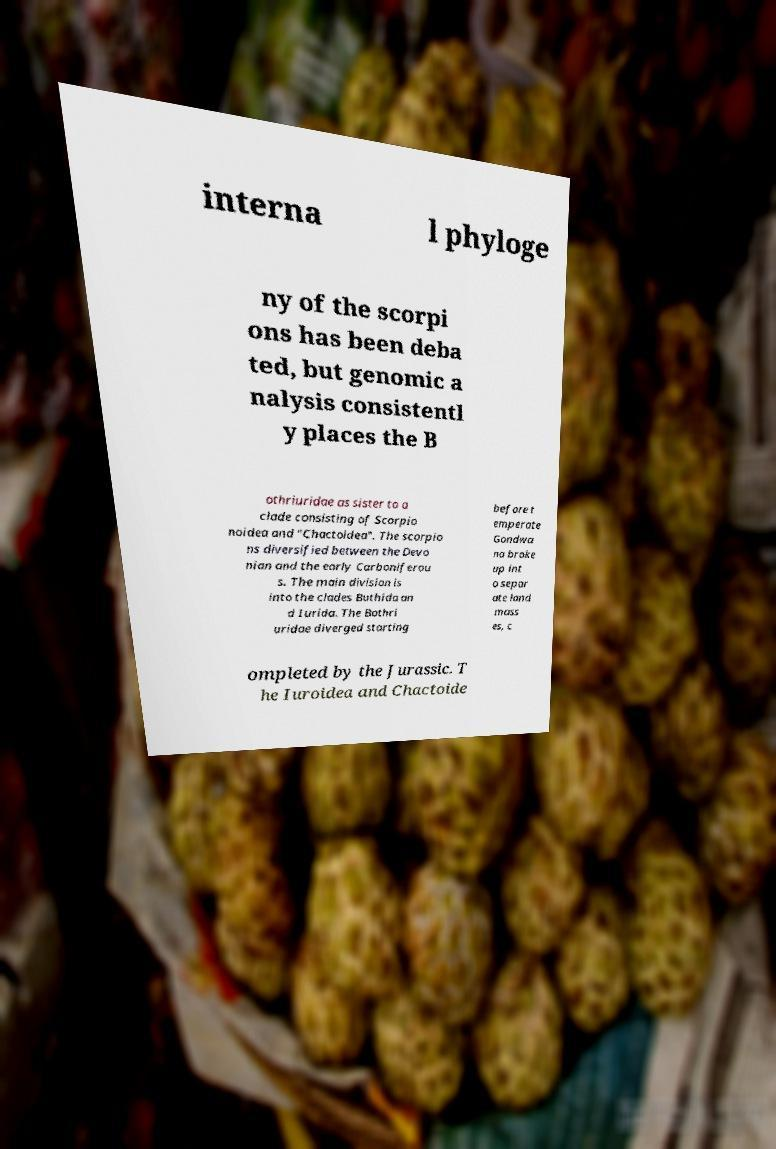What messages or text are displayed in this image? I need them in a readable, typed format. interna l phyloge ny of the scorpi ons has been deba ted, but genomic a nalysis consistentl y places the B othriuridae as sister to a clade consisting of Scorpio noidea and "Chactoidea". The scorpio ns diversified between the Devo nian and the early Carboniferou s. The main division is into the clades Buthida an d Iurida. The Bothri uridae diverged starting before t emperate Gondwa na broke up int o separ ate land mass es, c ompleted by the Jurassic. T he Iuroidea and Chactoide 